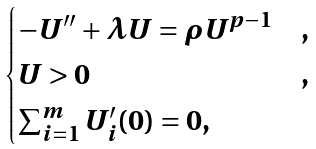Convert formula to latex. <formula><loc_0><loc_0><loc_500><loc_500>\begin{cases} - U ^ { \prime \prime } + \lambda U = \rho U ^ { p - 1 } & , \\ U > 0 & , \\ \sum _ { i = 1 } ^ { m } U _ { i } ^ { \prime } ( 0 ) = 0 , \end{cases}</formula> 